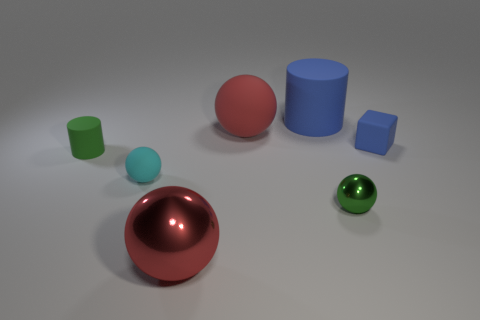Subtract all small metal spheres. How many spheres are left? 3 Subtract all gray blocks. How many red balls are left? 2 Add 1 brown metal cylinders. How many objects exist? 8 Subtract all green spheres. How many spheres are left? 3 Subtract all balls. How many objects are left? 3 Add 5 blue shiny cylinders. How many blue shiny cylinders exist? 5 Subtract 1 blue cylinders. How many objects are left? 6 Subtract all gray cubes. Subtract all cyan cylinders. How many cubes are left? 1 Subtract all big objects. Subtract all blocks. How many objects are left? 3 Add 7 green matte things. How many green matte things are left? 8 